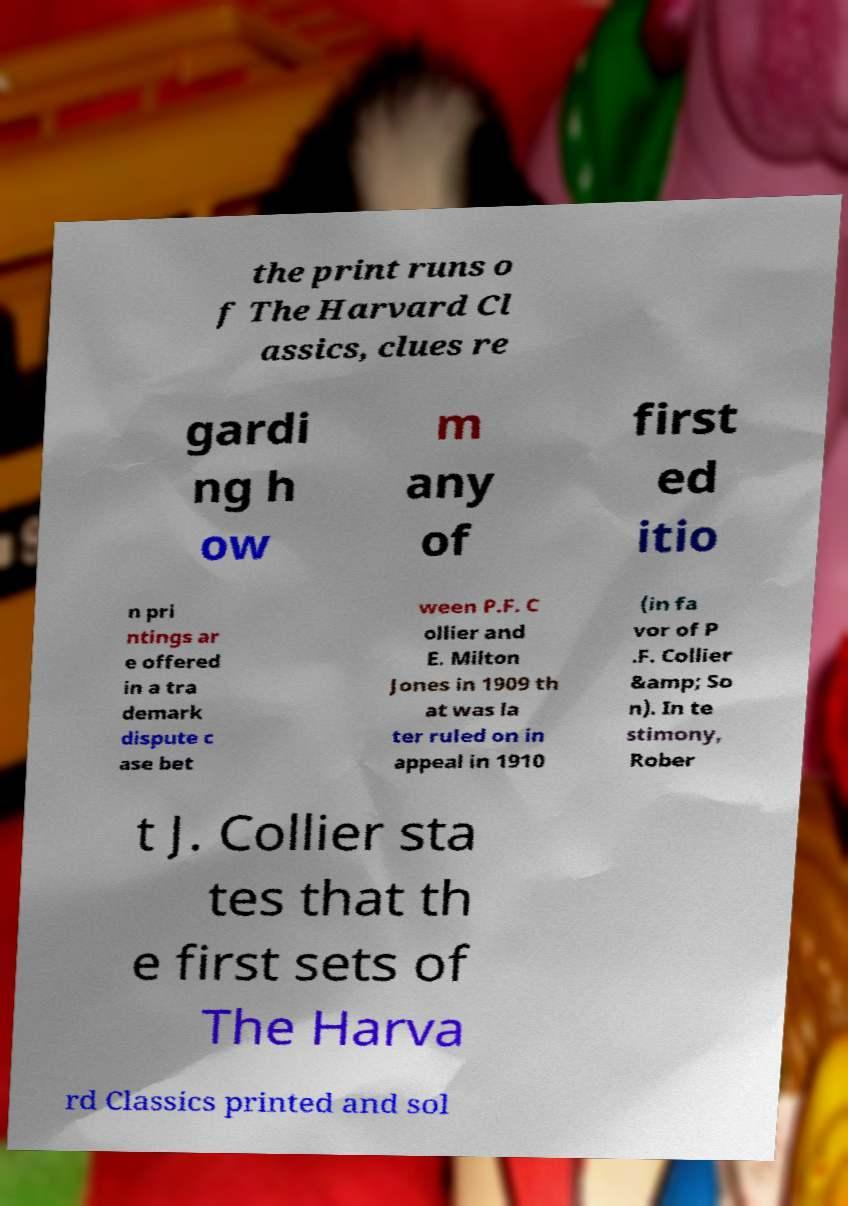Can you accurately transcribe the text from the provided image for me? the print runs o f The Harvard Cl assics, clues re gardi ng h ow m any of first ed itio n pri ntings ar e offered in a tra demark dispute c ase bet ween P.F. C ollier and E. Milton Jones in 1909 th at was la ter ruled on in appeal in 1910 (in fa vor of P .F. Collier &amp; So n). In te stimony, Rober t J. Collier sta tes that th e first sets of The Harva rd Classics printed and sol 